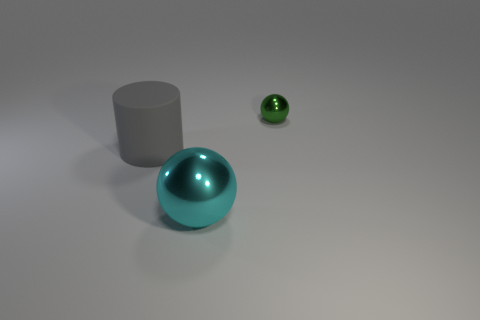Add 2 cyan shiny cubes. How many objects exist? 5 Subtract all cylinders. How many objects are left? 2 Subtract all tiny green spheres. Subtract all large cylinders. How many objects are left? 1 Add 3 large cyan shiny objects. How many large cyan shiny objects are left? 4 Add 2 big green metallic cylinders. How many big green metallic cylinders exist? 2 Subtract 0 gray cubes. How many objects are left? 3 